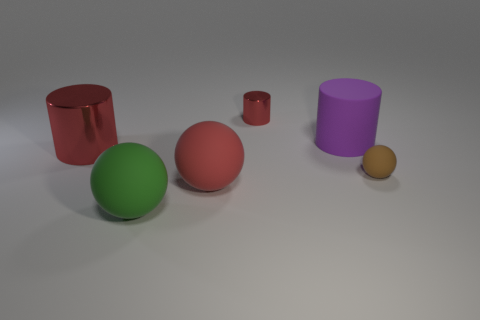Add 2 gray things. How many objects exist? 8 Add 4 red matte things. How many red matte things exist? 5 Subtract 0 purple blocks. How many objects are left? 6 Subtract all tiny balls. Subtract all small brown rubber spheres. How many objects are left? 4 Add 1 small brown matte balls. How many small brown matte balls are left? 2 